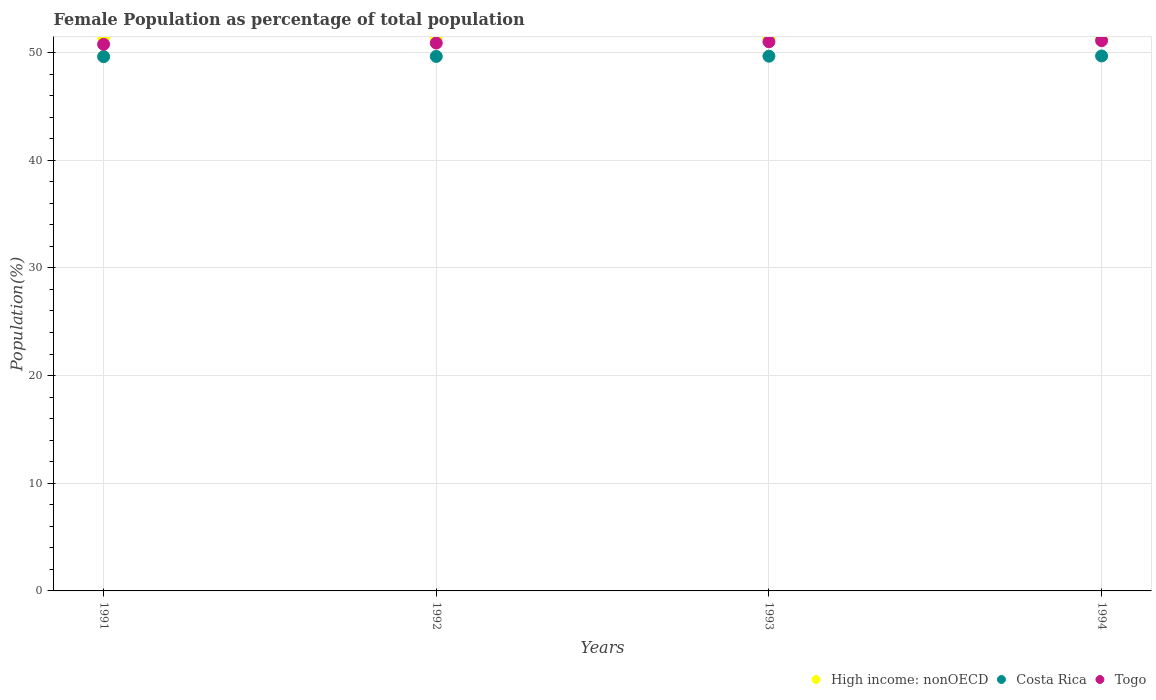What is the female population in in Togo in 1993?
Ensure brevity in your answer.  51. Across all years, what is the maximum female population in in High income: nonOECD?
Give a very brief answer. 51.39. Across all years, what is the minimum female population in in Costa Rica?
Give a very brief answer. 49.62. In which year was the female population in in High income: nonOECD maximum?
Provide a short and direct response. 1991. In which year was the female population in in High income: nonOECD minimum?
Provide a succinct answer. 1994. What is the total female population in in Togo in the graph?
Offer a very short reply. 203.74. What is the difference between the female population in in Costa Rica in 1991 and that in 1993?
Give a very brief answer. -0.04. What is the difference between the female population in in Togo in 1993 and the female population in in High income: nonOECD in 1992?
Offer a terse response. -0.38. What is the average female population in in Togo per year?
Make the answer very short. 50.93. In the year 1992, what is the difference between the female population in in Togo and female population in in Costa Rica?
Offer a very short reply. 1.24. What is the ratio of the female population in in High income: nonOECD in 1991 to that in 1994?
Offer a very short reply. 1. Is the difference between the female population in in Togo in 1992 and 1993 greater than the difference between the female population in in Costa Rica in 1992 and 1993?
Your answer should be compact. No. What is the difference between the highest and the second highest female population in in Costa Rica?
Give a very brief answer. 0.02. What is the difference between the highest and the lowest female population in in High income: nonOECD?
Your answer should be very brief. 0.07. In how many years, is the female population in in Costa Rica greater than the average female population in in Costa Rica taken over all years?
Give a very brief answer. 2. Is the sum of the female population in in Togo in 1991 and 1993 greater than the maximum female population in in High income: nonOECD across all years?
Make the answer very short. Yes. Is it the case that in every year, the sum of the female population in in Togo and female population in in High income: nonOECD  is greater than the female population in in Costa Rica?
Your answer should be compact. Yes. Is the female population in in Togo strictly greater than the female population in in High income: nonOECD over the years?
Provide a short and direct response. No. How many years are there in the graph?
Ensure brevity in your answer.  4. Are the values on the major ticks of Y-axis written in scientific E-notation?
Offer a very short reply. No. Does the graph contain any zero values?
Provide a short and direct response. No. Does the graph contain grids?
Offer a terse response. Yes. Where does the legend appear in the graph?
Your answer should be compact. Bottom right. What is the title of the graph?
Your response must be concise. Female Population as percentage of total population. Does "High income" appear as one of the legend labels in the graph?
Provide a short and direct response. No. What is the label or title of the Y-axis?
Ensure brevity in your answer.  Population(%). What is the Population(%) in High income: nonOECD in 1991?
Offer a very short reply. 51.39. What is the Population(%) of Costa Rica in 1991?
Offer a very short reply. 49.62. What is the Population(%) in Togo in 1991?
Make the answer very short. 50.76. What is the Population(%) of High income: nonOECD in 1992?
Ensure brevity in your answer.  51.38. What is the Population(%) of Costa Rica in 1992?
Offer a terse response. 49.64. What is the Population(%) in Togo in 1992?
Keep it short and to the point. 50.88. What is the Population(%) in High income: nonOECD in 1993?
Give a very brief answer. 51.35. What is the Population(%) in Costa Rica in 1993?
Ensure brevity in your answer.  49.66. What is the Population(%) of Togo in 1993?
Make the answer very short. 51. What is the Population(%) of High income: nonOECD in 1994?
Your answer should be very brief. 51.32. What is the Population(%) of Costa Rica in 1994?
Provide a short and direct response. 49.68. What is the Population(%) in Togo in 1994?
Offer a very short reply. 51.1. Across all years, what is the maximum Population(%) in High income: nonOECD?
Offer a terse response. 51.39. Across all years, what is the maximum Population(%) of Costa Rica?
Make the answer very short. 49.68. Across all years, what is the maximum Population(%) in Togo?
Keep it short and to the point. 51.1. Across all years, what is the minimum Population(%) in High income: nonOECD?
Ensure brevity in your answer.  51.32. Across all years, what is the minimum Population(%) of Costa Rica?
Give a very brief answer. 49.62. Across all years, what is the minimum Population(%) of Togo?
Provide a succinct answer. 50.76. What is the total Population(%) in High income: nonOECD in the graph?
Your response must be concise. 205.44. What is the total Population(%) in Costa Rica in the graph?
Your response must be concise. 198.59. What is the total Population(%) of Togo in the graph?
Keep it short and to the point. 203.74. What is the difference between the Population(%) of High income: nonOECD in 1991 and that in 1992?
Offer a very short reply. 0.01. What is the difference between the Population(%) in Costa Rica in 1991 and that in 1992?
Offer a terse response. -0.02. What is the difference between the Population(%) of Togo in 1991 and that in 1992?
Make the answer very short. -0.12. What is the difference between the Population(%) in High income: nonOECD in 1991 and that in 1993?
Your answer should be compact. 0.04. What is the difference between the Population(%) of Costa Rica in 1991 and that in 1993?
Offer a terse response. -0.04. What is the difference between the Population(%) of Togo in 1991 and that in 1993?
Ensure brevity in your answer.  -0.24. What is the difference between the Population(%) of High income: nonOECD in 1991 and that in 1994?
Provide a short and direct response. 0.07. What is the difference between the Population(%) of Costa Rica in 1991 and that in 1994?
Offer a very short reply. -0.06. What is the difference between the Population(%) in Togo in 1991 and that in 1994?
Your answer should be very brief. -0.34. What is the difference between the Population(%) of High income: nonOECD in 1992 and that in 1993?
Your answer should be very brief. 0.04. What is the difference between the Population(%) in Costa Rica in 1992 and that in 1993?
Provide a succinct answer. -0.02. What is the difference between the Population(%) in Togo in 1992 and that in 1993?
Your response must be concise. -0.12. What is the difference between the Population(%) in High income: nonOECD in 1992 and that in 1994?
Give a very brief answer. 0.06. What is the difference between the Population(%) in Costa Rica in 1992 and that in 1994?
Your response must be concise. -0.04. What is the difference between the Population(%) of Togo in 1992 and that in 1994?
Keep it short and to the point. -0.22. What is the difference between the Population(%) in High income: nonOECD in 1993 and that in 1994?
Your response must be concise. 0.02. What is the difference between the Population(%) of Costa Rica in 1993 and that in 1994?
Make the answer very short. -0.02. What is the difference between the Population(%) of Togo in 1993 and that in 1994?
Make the answer very short. -0.1. What is the difference between the Population(%) of High income: nonOECD in 1991 and the Population(%) of Costa Rica in 1992?
Keep it short and to the point. 1.75. What is the difference between the Population(%) in High income: nonOECD in 1991 and the Population(%) in Togo in 1992?
Provide a short and direct response. 0.51. What is the difference between the Population(%) in Costa Rica in 1991 and the Population(%) in Togo in 1992?
Make the answer very short. -1.26. What is the difference between the Population(%) of High income: nonOECD in 1991 and the Population(%) of Costa Rica in 1993?
Offer a very short reply. 1.73. What is the difference between the Population(%) of High income: nonOECD in 1991 and the Population(%) of Togo in 1993?
Ensure brevity in your answer.  0.39. What is the difference between the Population(%) of Costa Rica in 1991 and the Population(%) of Togo in 1993?
Ensure brevity in your answer.  -1.38. What is the difference between the Population(%) in High income: nonOECD in 1991 and the Population(%) in Costa Rica in 1994?
Provide a succinct answer. 1.71. What is the difference between the Population(%) in High income: nonOECD in 1991 and the Population(%) in Togo in 1994?
Make the answer very short. 0.29. What is the difference between the Population(%) of Costa Rica in 1991 and the Population(%) of Togo in 1994?
Ensure brevity in your answer.  -1.48. What is the difference between the Population(%) in High income: nonOECD in 1992 and the Population(%) in Costa Rica in 1993?
Your response must be concise. 1.73. What is the difference between the Population(%) of High income: nonOECD in 1992 and the Population(%) of Togo in 1993?
Make the answer very short. 0.38. What is the difference between the Population(%) of Costa Rica in 1992 and the Population(%) of Togo in 1993?
Keep it short and to the point. -1.36. What is the difference between the Population(%) in High income: nonOECD in 1992 and the Population(%) in Costa Rica in 1994?
Your response must be concise. 1.7. What is the difference between the Population(%) of High income: nonOECD in 1992 and the Population(%) of Togo in 1994?
Give a very brief answer. 0.28. What is the difference between the Population(%) in Costa Rica in 1992 and the Population(%) in Togo in 1994?
Make the answer very short. -1.46. What is the difference between the Population(%) in High income: nonOECD in 1993 and the Population(%) in Costa Rica in 1994?
Keep it short and to the point. 1.67. What is the difference between the Population(%) in High income: nonOECD in 1993 and the Population(%) in Togo in 1994?
Provide a short and direct response. 0.24. What is the difference between the Population(%) of Costa Rica in 1993 and the Population(%) of Togo in 1994?
Offer a very short reply. -1.44. What is the average Population(%) in High income: nonOECD per year?
Give a very brief answer. 51.36. What is the average Population(%) of Costa Rica per year?
Your answer should be compact. 49.65. What is the average Population(%) of Togo per year?
Keep it short and to the point. 50.94. In the year 1991, what is the difference between the Population(%) in High income: nonOECD and Population(%) in Costa Rica?
Offer a very short reply. 1.77. In the year 1991, what is the difference between the Population(%) of High income: nonOECD and Population(%) of Togo?
Your answer should be very brief. 0.63. In the year 1991, what is the difference between the Population(%) in Costa Rica and Population(%) in Togo?
Make the answer very short. -1.15. In the year 1992, what is the difference between the Population(%) of High income: nonOECD and Population(%) of Costa Rica?
Your answer should be very brief. 1.75. In the year 1992, what is the difference between the Population(%) of High income: nonOECD and Population(%) of Togo?
Provide a succinct answer. 0.5. In the year 1992, what is the difference between the Population(%) of Costa Rica and Population(%) of Togo?
Offer a terse response. -1.24. In the year 1993, what is the difference between the Population(%) in High income: nonOECD and Population(%) in Costa Rica?
Keep it short and to the point. 1.69. In the year 1993, what is the difference between the Population(%) of High income: nonOECD and Population(%) of Togo?
Provide a short and direct response. 0.35. In the year 1993, what is the difference between the Population(%) in Costa Rica and Population(%) in Togo?
Keep it short and to the point. -1.34. In the year 1994, what is the difference between the Population(%) in High income: nonOECD and Population(%) in Costa Rica?
Your answer should be compact. 1.64. In the year 1994, what is the difference between the Population(%) of High income: nonOECD and Population(%) of Togo?
Provide a succinct answer. 0.22. In the year 1994, what is the difference between the Population(%) of Costa Rica and Population(%) of Togo?
Your answer should be compact. -1.42. What is the ratio of the Population(%) of High income: nonOECD in 1991 to that in 1992?
Your response must be concise. 1. What is the ratio of the Population(%) of Costa Rica in 1991 to that in 1992?
Offer a terse response. 1. What is the ratio of the Population(%) of Togo in 1991 to that in 1992?
Provide a short and direct response. 1. What is the ratio of the Population(%) of High income: nonOECD in 1991 to that in 1993?
Your response must be concise. 1. What is the ratio of the Population(%) in Costa Rica in 1991 to that in 1993?
Keep it short and to the point. 1. What is the ratio of the Population(%) in Togo in 1991 to that in 1993?
Offer a terse response. 1. What is the ratio of the Population(%) of High income: nonOECD in 1991 to that in 1994?
Give a very brief answer. 1. What is the ratio of the Population(%) in Togo in 1991 to that in 1994?
Give a very brief answer. 0.99. What is the ratio of the Population(%) in Costa Rica in 1992 to that in 1994?
Ensure brevity in your answer.  1. What is the ratio of the Population(%) in Togo in 1992 to that in 1994?
Your answer should be compact. 1. What is the ratio of the Population(%) of Togo in 1993 to that in 1994?
Your response must be concise. 1. What is the difference between the highest and the second highest Population(%) in High income: nonOECD?
Make the answer very short. 0.01. What is the difference between the highest and the second highest Population(%) in Costa Rica?
Your response must be concise. 0.02. What is the difference between the highest and the second highest Population(%) in Togo?
Offer a terse response. 0.1. What is the difference between the highest and the lowest Population(%) of High income: nonOECD?
Offer a very short reply. 0.07. What is the difference between the highest and the lowest Population(%) of Costa Rica?
Make the answer very short. 0.06. What is the difference between the highest and the lowest Population(%) in Togo?
Ensure brevity in your answer.  0.34. 